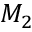Convert formula to latex. <formula><loc_0><loc_0><loc_500><loc_500>M _ { 2 }</formula> 